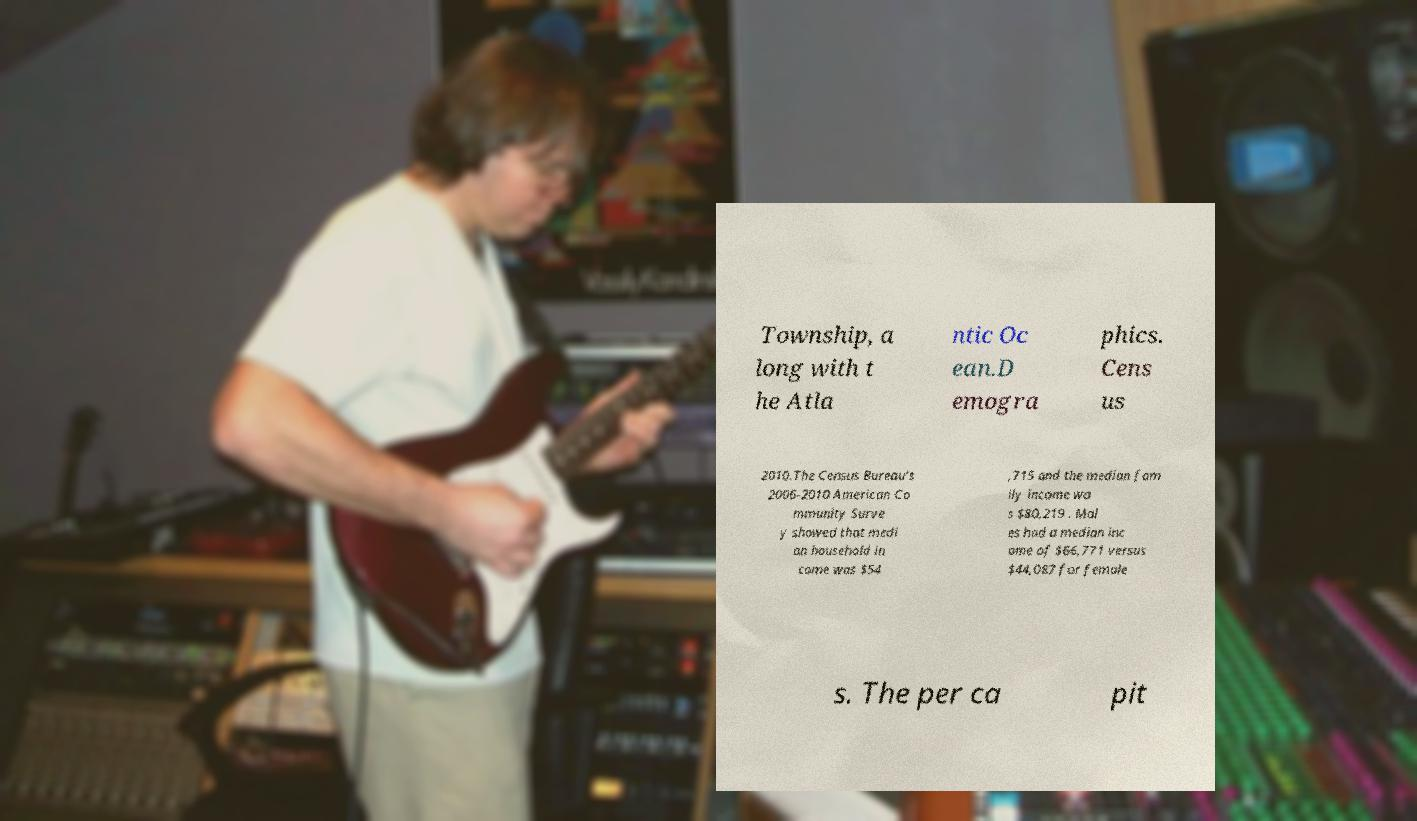There's text embedded in this image that I need extracted. Can you transcribe it verbatim? Township, a long with t he Atla ntic Oc ean.D emogra phics. Cens us 2010.The Census Bureau's 2006-2010 American Co mmunity Surve y showed that medi an household in come was $54 ,715 and the median fam ily income wa s $80,219 . Mal es had a median inc ome of $66,771 versus $44,087 for female s. The per ca pit 